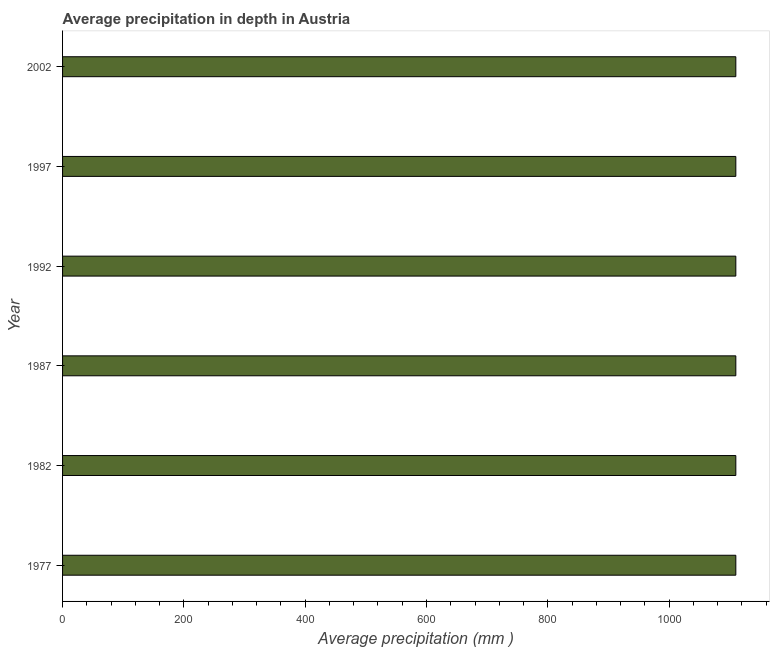Does the graph contain grids?
Offer a terse response. No. What is the title of the graph?
Provide a succinct answer. Average precipitation in depth in Austria. What is the label or title of the X-axis?
Make the answer very short. Average precipitation (mm ). What is the label or title of the Y-axis?
Your response must be concise. Year. What is the average precipitation in depth in 1977?
Keep it short and to the point. 1110. Across all years, what is the maximum average precipitation in depth?
Offer a terse response. 1110. Across all years, what is the minimum average precipitation in depth?
Provide a short and direct response. 1110. What is the sum of the average precipitation in depth?
Provide a succinct answer. 6660. What is the average average precipitation in depth per year?
Make the answer very short. 1110. What is the median average precipitation in depth?
Offer a very short reply. 1110. In how many years, is the average precipitation in depth greater than 560 mm?
Your answer should be compact. 6. Do a majority of the years between 1992 and 1997 (inclusive) have average precipitation in depth greater than 40 mm?
Your answer should be very brief. Yes. What is the ratio of the average precipitation in depth in 1977 to that in 1987?
Give a very brief answer. 1. Is the average precipitation in depth in 1997 less than that in 2002?
Ensure brevity in your answer.  No. Is the difference between the average precipitation in depth in 1987 and 1992 greater than the difference between any two years?
Give a very brief answer. Yes. How many bars are there?
Offer a very short reply. 6. How many years are there in the graph?
Make the answer very short. 6. What is the difference between two consecutive major ticks on the X-axis?
Offer a very short reply. 200. Are the values on the major ticks of X-axis written in scientific E-notation?
Provide a short and direct response. No. What is the Average precipitation (mm ) of 1977?
Offer a terse response. 1110. What is the Average precipitation (mm ) of 1982?
Offer a very short reply. 1110. What is the Average precipitation (mm ) of 1987?
Give a very brief answer. 1110. What is the Average precipitation (mm ) in 1992?
Your answer should be compact. 1110. What is the Average precipitation (mm ) in 1997?
Offer a very short reply. 1110. What is the Average precipitation (mm ) in 2002?
Provide a succinct answer. 1110. What is the difference between the Average precipitation (mm ) in 1977 and 1987?
Make the answer very short. 0. What is the difference between the Average precipitation (mm ) in 1977 and 1992?
Provide a short and direct response. 0. What is the difference between the Average precipitation (mm ) in 1982 and 1992?
Make the answer very short. 0. What is the difference between the Average precipitation (mm ) in 1982 and 2002?
Your response must be concise. 0. What is the difference between the Average precipitation (mm ) in 1992 and 1997?
Make the answer very short. 0. What is the difference between the Average precipitation (mm ) in 1992 and 2002?
Make the answer very short. 0. What is the ratio of the Average precipitation (mm ) in 1977 to that in 1982?
Offer a very short reply. 1. What is the ratio of the Average precipitation (mm ) in 1977 to that in 2002?
Make the answer very short. 1. What is the ratio of the Average precipitation (mm ) in 1982 to that in 1992?
Ensure brevity in your answer.  1. What is the ratio of the Average precipitation (mm ) in 1982 to that in 1997?
Your answer should be compact. 1. What is the ratio of the Average precipitation (mm ) in 1987 to that in 1992?
Provide a succinct answer. 1. What is the ratio of the Average precipitation (mm ) in 1987 to that in 1997?
Offer a terse response. 1. What is the ratio of the Average precipitation (mm ) in 1992 to that in 1997?
Keep it short and to the point. 1. What is the ratio of the Average precipitation (mm ) in 1997 to that in 2002?
Offer a very short reply. 1. 